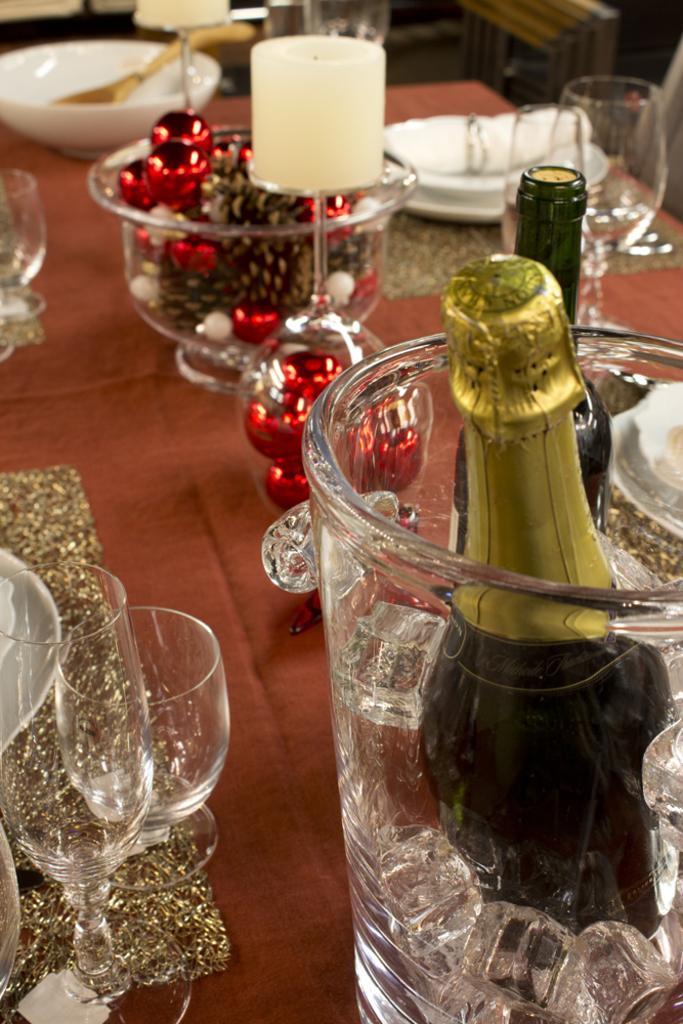Can you describe this image briefly? In this picture, there are some glasses, food items in the bowl on the table. We can observe a champagne bottle placed in ice cubes jar on the table. 